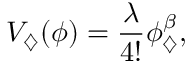<formula> <loc_0><loc_0><loc_500><loc_500>V _ { \diamondsuit } ( \phi ) = \frac { \lambda } { 4 ! } \phi _ { \diamondsuit } ^ { \beta } ,</formula> 